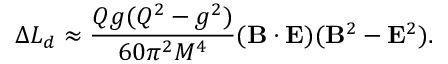<formula> <loc_0><loc_0><loc_500><loc_500>\Delta L _ { d } \approx \frac { Q g ( Q ^ { 2 } - g ^ { 2 } ) } { 6 0 \pi ^ { 2 } M ^ { 4 } } ( { B } \cdot { E } ) ( { B } ^ { 2 } - { E } ^ { 2 } ) .</formula> 